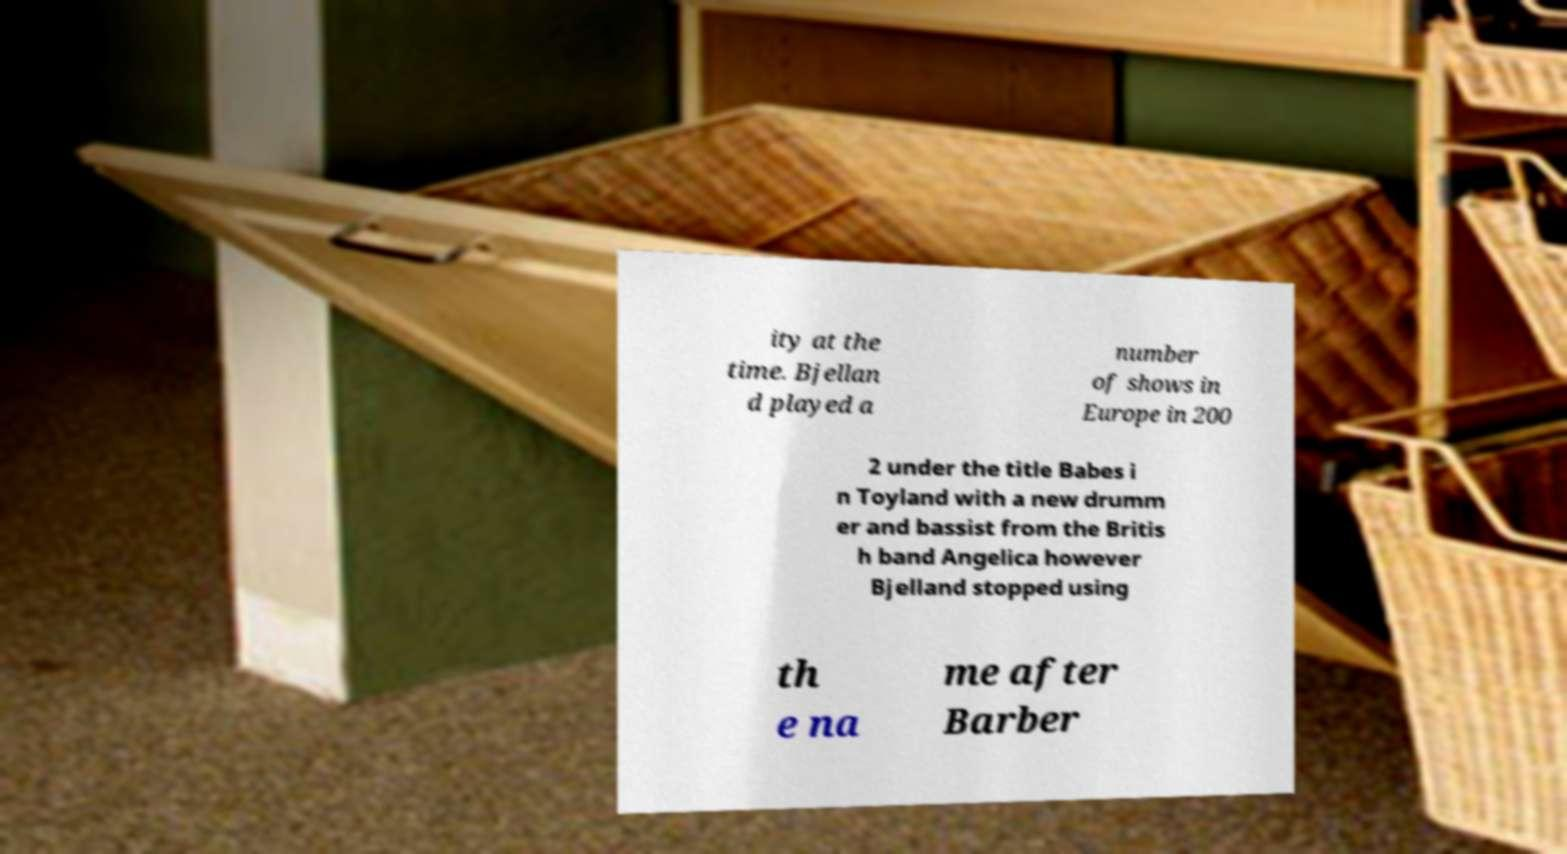There's text embedded in this image that I need extracted. Can you transcribe it verbatim? ity at the time. Bjellan d played a number of shows in Europe in 200 2 under the title Babes i n Toyland with a new drumm er and bassist from the Britis h band Angelica however Bjelland stopped using th e na me after Barber 